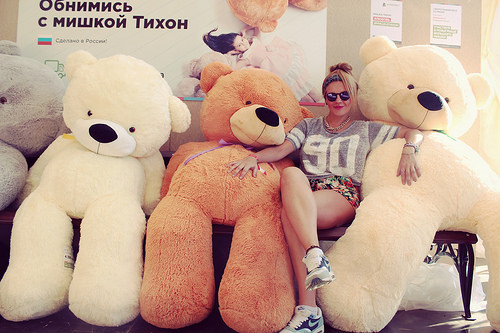<image>
Is the women to the left of the brown teddy? Yes. From this viewpoint, the women is positioned to the left side relative to the brown teddy. Where is the bear in relation to the woman? Is it in front of the woman? No. The bear is not in front of the woman. The spatial positioning shows a different relationship between these objects. 